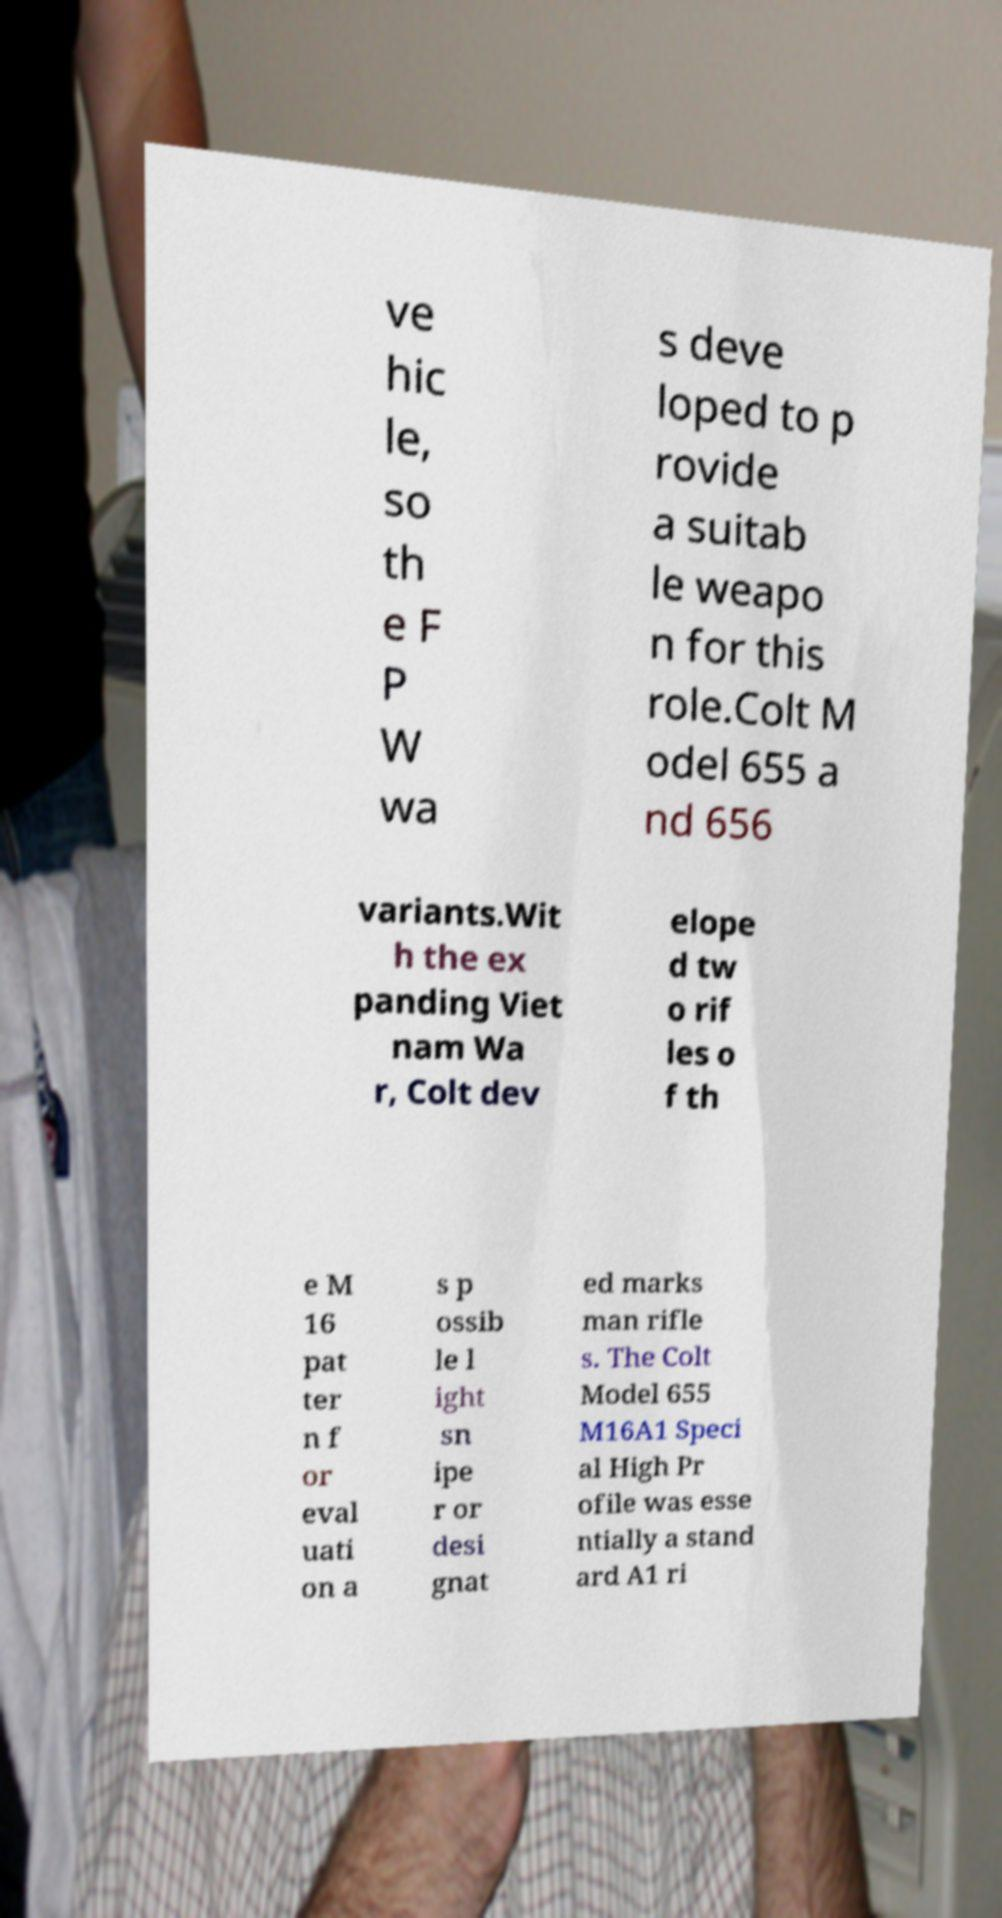For documentation purposes, I need the text within this image transcribed. Could you provide that? ve hic le, so th e F P W wa s deve loped to p rovide a suitab le weapo n for this role.Colt M odel 655 a nd 656 variants.Wit h the ex panding Viet nam Wa r, Colt dev elope d tw o rif les o f th e M 16 pat ter n f or eval uati on a s p ossib le l ight sn ipe r or desi gnat ed marks man rifle s. The Colt Model 655 M16A1 Speci al High Pr ofile was esse ntially a stand ard A1 ri 